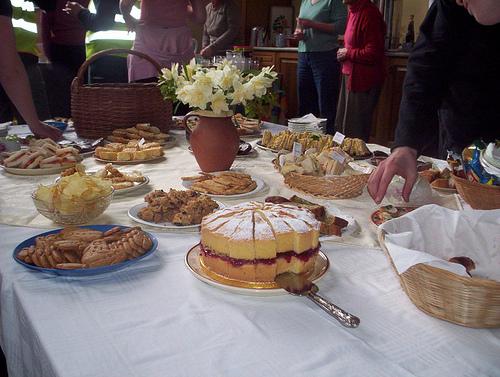Do you think this is the dessert table?
Be succinct. Yes. What color are the flowers in the centerpiece?
Keep it brief. White. How many pieces is the cake cut into?
Keep it brief. 14. How many deserts are shown?
Short answer required. 10. 